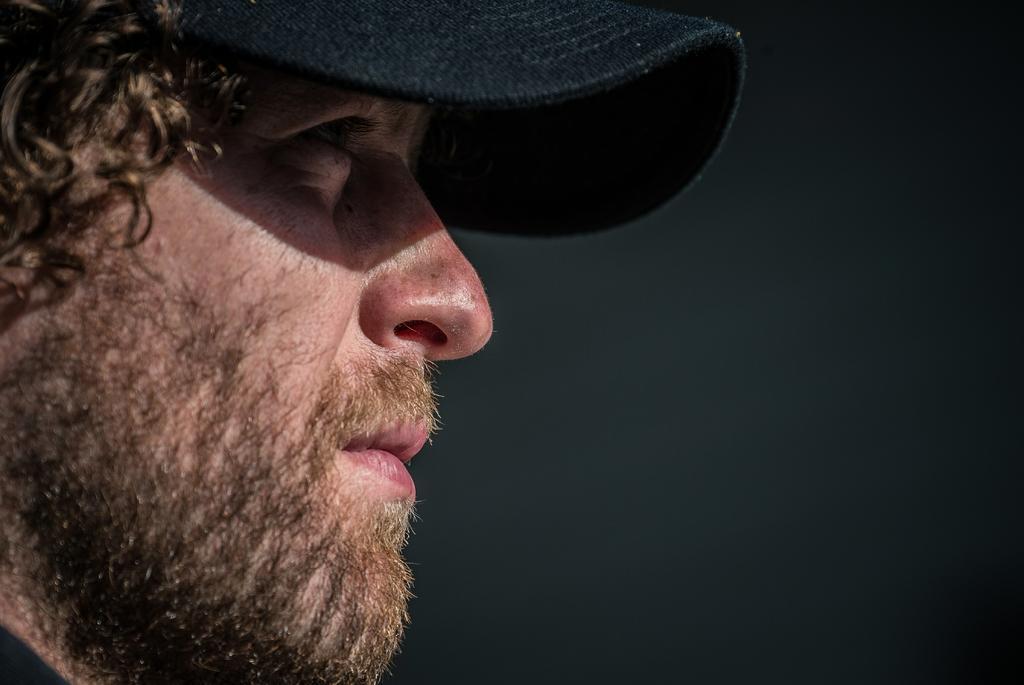Please provide a concise description of this image. As we can see in the image on the left side there is a man wearing black color cap. 